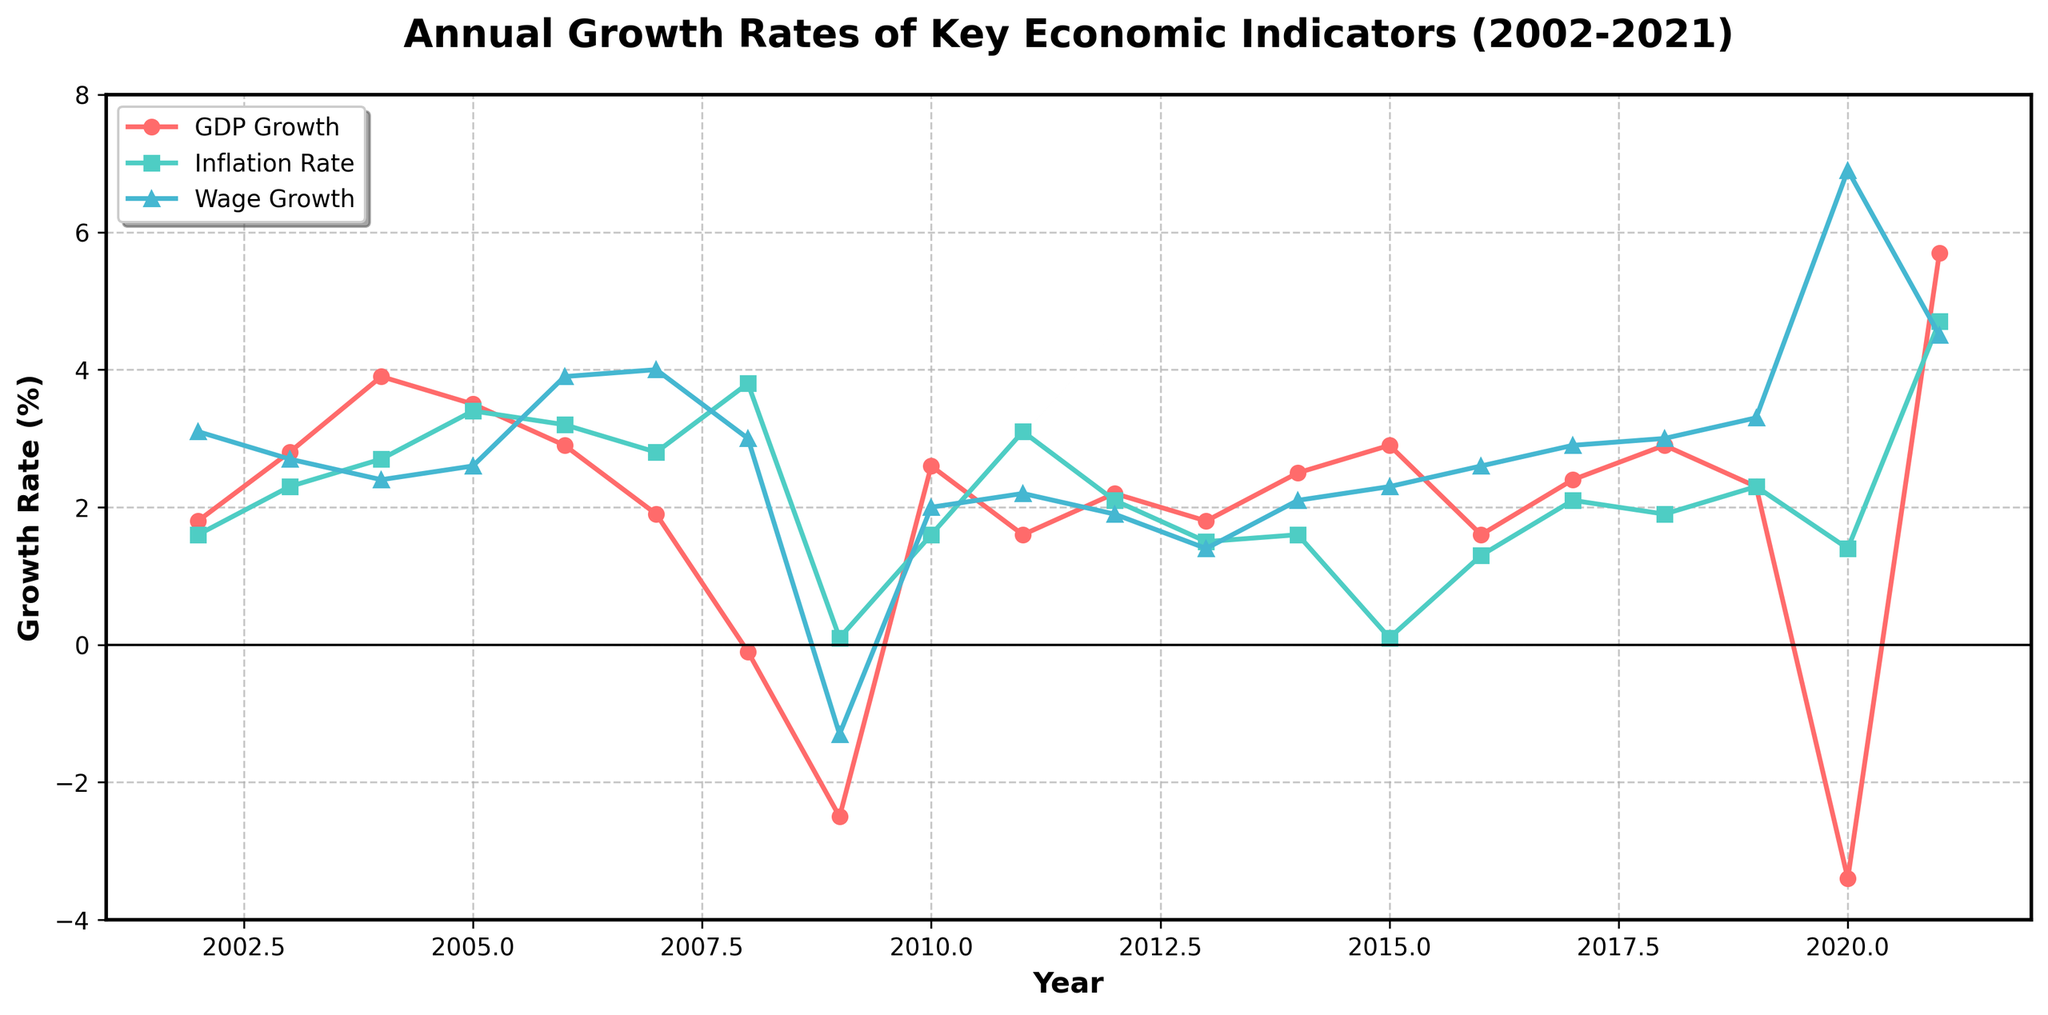What was the GDP growth rate in 2009 and how did it compare to the GDP growth rate in 2021? To compare the GDP growth rates in 2009 and 2021, observe the GDP Growth line for these years. In 2009, GDP growth was -2.5%, and in 2021, it was 5.7%. Therefore, GDP growth in 2021 was much higher than in 2009.
Answer: 5.7% higher Which year shows the largest difference between GDP growth rate and inflation rate, and what is the difference? To find the year with the largest difference between GDP growth rate and inflation rate, calculate the absolute differences for each year. The year with the largest difference is 2009, with a GDP growth rate of -2.5% and an inflation rate of 0.1%, resulting in a difference of 2.6%.
Answer: 2009, 2.6% During which years did wage growth exceed GDP growth? Identify the years in which the value of the Wage Growth line is above the GDP Growth line. These years are 2006, 2007, 2008, 2019, 2020, and 2021.
Answer: 2006, 2007, 2008, 2019, 2020, 2021 What is the average GDP growth rate for the first decade (2002-2011)? Sum the GDP growth rates from 2002 to 2011 and divide by the number of years. Sum: 1.8 + 2.8 + 3.9 + 3.5 + 2.9 + 1.9 - 0.1 - 2.5 + 2.6 + 1.6 = 18.4. The number of years is 10, therefore the average GDP growth rate: 18.4 / 10 = 1.84%.
Answer: 1.84% In which year did the inflation rate peak, and what was its value? Find the highest point on the Inflation Rate line. The peak occurs in 2021 with an inflation rate of 4.7%.
Answer: 2021, 4.7% How did wage growth change from 2010 to 2011? Observe the Wage Growth line between 2010 and 2011. In 2010, wage growth was 2.0%, and in 2011, it was 2.2%, indicating an increase of 0.2%.
Answer: Increased by 0.2% What was the trend in GDP growth from 2005 to 2009? Look at the GDP Growth line from 2005 to 2009. In 2005, GDP growth was 3.5%, which then trended downwards to -2.5% in 2009.
Answer: Downward trend Compare the GDP growth rate and wage growth rate in 2020. Which one had a more significant change from the previous year? Compare changes from 2019 to 2020 for both GDP and Wage Growth. GDP growth went from 2.3% to -3.4% (a decrease of 5.7%), and wage growth went from 3.3% to 6.9% (an increase of 3.6%). GDP growth had a more significant change.
Answer: GDP growth Which indicator had the most stable growth rate over the period 2002-2021, and what evidence supports this? Observe fluctuations in the lines. Wage growth shows relatively smaller and more consistent fluctuations compared to GDP growth and inflation rate. Hence, wage growth is the most stable.
Answer: Wage growth 